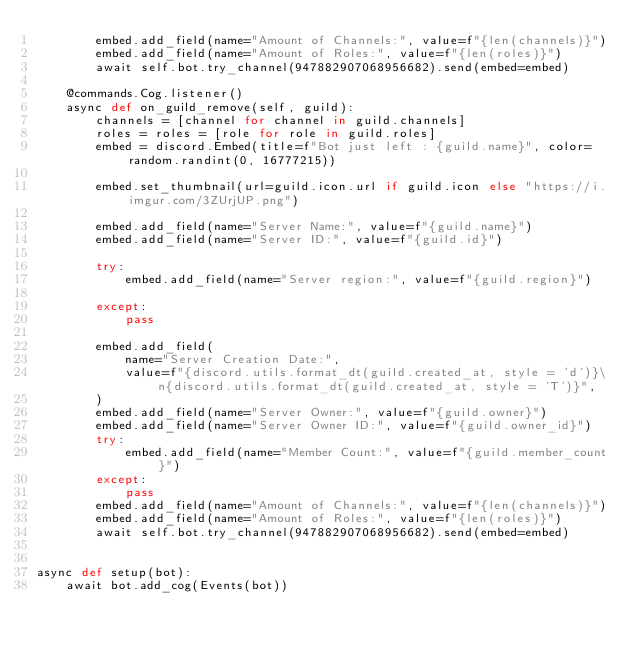<code> <loc_0><loc_0><loc_500><loc_500><_Python_>        embed.add_field(name="Amount of Channels:", value=f"{len(channels)}")
        embed.add_field(name="Amount of Roles:", value=f"{len(roles)}")
        await self.bot.try_channel(947882907068956682).send(embed=embed)

    @commands.Cog.listener()
    async def on_guild_remove(self, guild):
        channels = [channel for channel in guild.channels]
        roles = roles = [role for role in guild.roles]
        embed = discord.Embed(title=f"Bot just left : {guild.name}", color=random.randint(0, 16777215))

        embed.set_thumbnail(url=guild.icon.url if guild.icon else "https://i.imgur.com/3ZUrjUP.png")

        embed.add_field(name="Server Name:", value=f"{guild.name}")
        embed.add_field(name="Server ID:", value=f"{guild.id}")

        try:
            embed.add_field(name="Server region:", value=f"{guild.region}")

        except:
            pass

        embed.add_field(
            name="Server Creation Date:",
            value=f"{discord.utils.format_dt(guild.created_at, style = 'd')}\n{discord.utils.format_dt(guild.created_at, style = 'T')}",
        )
        embed.add_field(name="Server Owner:", value=f"{guild.owner}")
        embed.add_field(name="Server Owner ID:", value=f"{guild.owner_id}")
        try:
            embed.add_field(name="Member Count:", value=f"{guild.member_count}")
        except:
            pass
        embed.add_field(name="Amount of Channels:", value=f"{len(channels)}")
        embed.add_field(name="Amount of Roles:", value=f"{len(roles)}")
        await self.bot.try_channel(947882907068956682).send(embed=embed)


async def setup(bot):
    await bot.add_cog(Events(bot))
</code> 